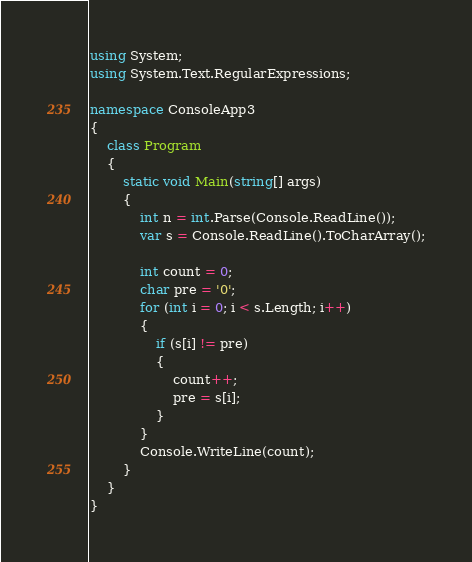Convert code to text. <code><loc_0><loc_0><loc_500><loc_500><_C#_>using System;
using System.Text.RegularExpressions;

namespace ConsoleApp3
{
	class Program
	{
		static void Main(string[] args)
		{
			int n = int.Parse(Console.ReadLine());
			var s = Console.ReadLine().ToCharArray();

			int count = 0;
			char pre = '0';
			for (int i = 0; i < s.Length; i++)
			{
				if (s[i] != pre)
				{
					count++;
					pre = s[i];
				}
			}
			Console.WriteLine(count);
		}
	}
}
</code> 